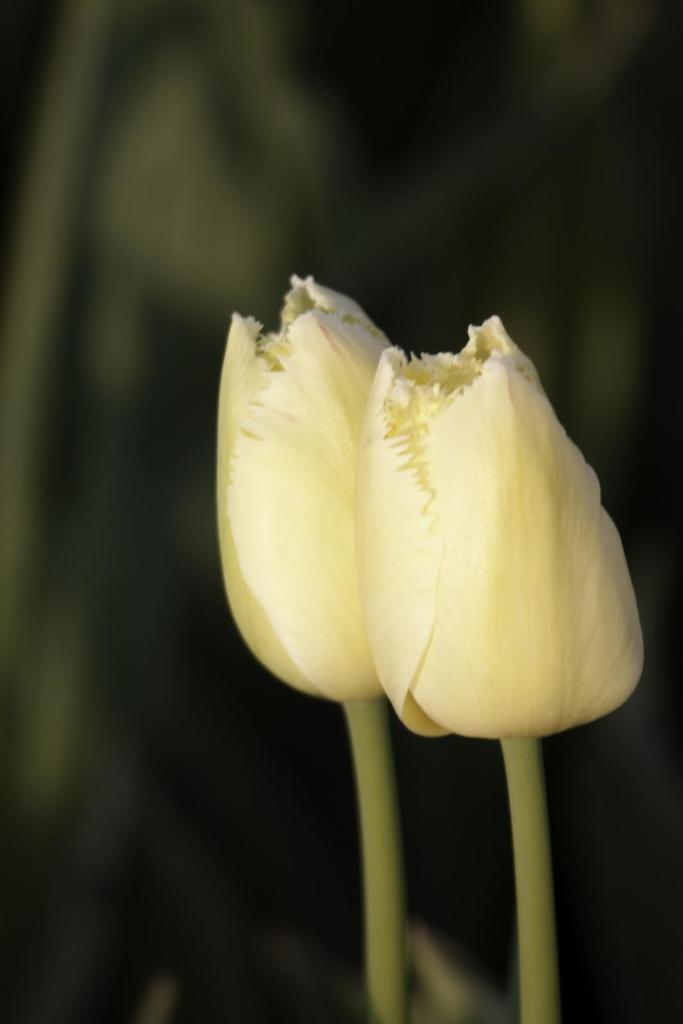What type of flowers can be seen in the image? There are white color flowers in the image. Can you describe the background of the image? The background of the image is green and black. Are there any crates visible in the image? There is no mention of crates in the provided facts, so we cannot determine if any are present in the image. Can you see any cobwebs in the image? There is no mention of cobwebs in the provided facts, so we cannot determine if any are present in the image. 